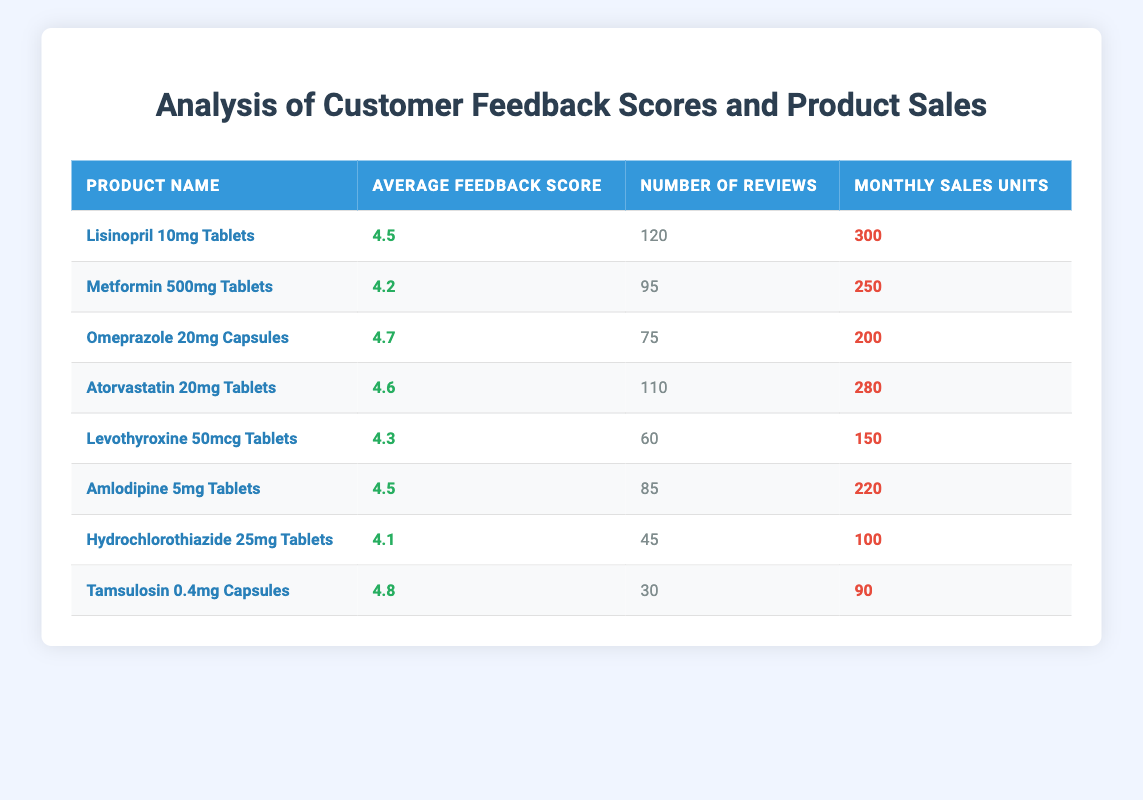What is the average feedback score for the product with the highest monthly sales units? The product with the highest monthly sales units is Lisinopril 10mg Tablets, which has an average feedback score of 4.5.
Answer: 4.5 How many reviews does the product with the lowest average feedback score have? The product with the lowest average feedback score is Hydrochlorothiazide 25mg Tablets, which has 45 reviews.
Answer: 45 Which product has the highest average feedback score, and what are its monthly sales units? Omeprazole 20mg Capsules has the highest average feedback score of 4.7 and its monthly sales units are 200.
Answer: Omeprazole 20mg Capsules, 200 What is the difference in monthly sales units between the product with the highest and lowest average feedback scores? The product with the highest average feedback score (Tamsulosin 0.4mg Capsules, 4.8) has 90 monthly sales units, and the product with the lowest average feedback score (Hydrochlorothiazide 25mg Tablets, 4.1) has 100 monthly sales units. The difference is 100 - 90 = 10.
Answer: 10 Do any products with an average feedback score above 4.5 have monthly sales units greater than 250? Yes, Lisinopril 10mg Tablets (4.5, 300 units) and Atorvastatin 20mg Tablets (4.6, 280 units) both meet this criteria.
Answer: Yes What is the average number of reviews for all products? To find the average number of reviews, add all the number of reviews (120 + 95 + 75 + 110 + 60 + 85 + 45 + 30 = 720) and divide by the number of products (8). The average is 720 / 8 = 90.
Answer: 90 Which product has the lowest number of reviews, and what is its feedback score? Hydrochlorothiazide 25mg Tablets has the lowest number of reviews, which is 45, and its feedback score is 4.1.
Answer: Hydrochlorothiazide 25mg Tablets, 4.1 How many total monthly sales units are there from products with an average feedback score of 4.5 or higher? The products with an average feedback score of 4.5 or higher are Lisinopril (300), Omeprazole (200), Atorvastatin (280), Amlodipine (220), and Tamsulosin (90). The total is 300 + 200 + 280 + 220 + 90 = 1090.
Answer: 1090 What percentage of total reviews comes from the product with the most reviews? The product with the most reviews is Lisinopril 10mg Tablets with 120 reviews. The total number of reviews is 720. The percentage is (120 / 720) * 100 = 16.67%.
Answer: 16.67% 